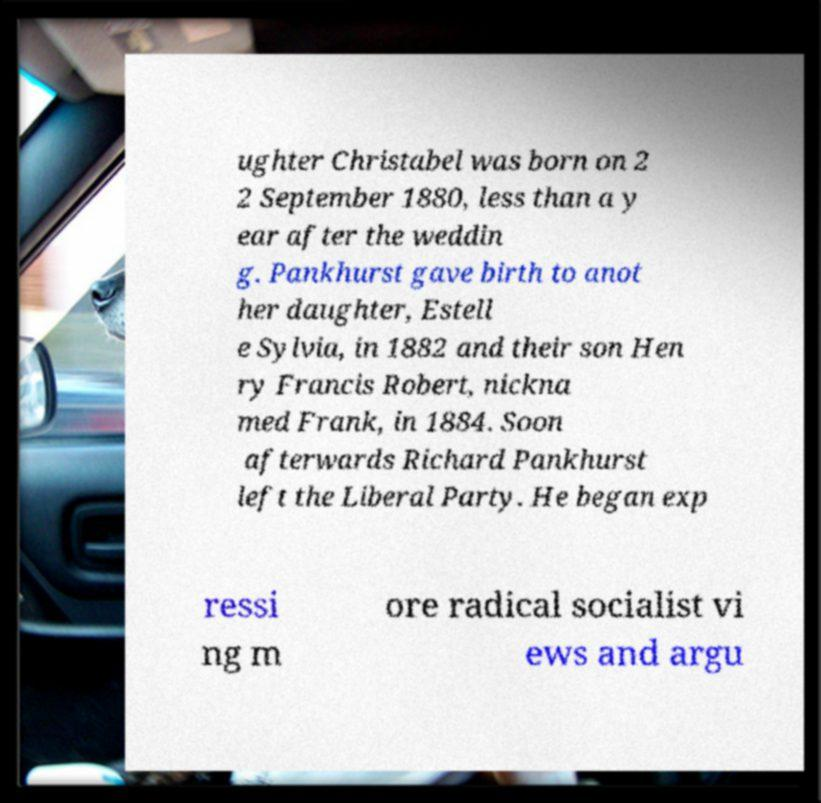Can you accurately transcribe the text from the provided image for me? ughter Christabel was born on 2 2 September 1880, less than a y ear after the weddin g. Pankhurst gave birth to anot her daughter, Estell e Sylvia, in 1882 and their son Hen ry Francis Robert, nickna med Frank, in 1884. Soon afterwards Richard Pankhurst left the Liberal Party. He began exp ressi ng m ore radical socialist vi ews and argu 